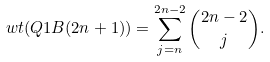Convert formula to latex. <formula><loc_0><loc_0><loc_500><loc_500>w t ( Q 1 B ( 2 n + 1 ) ) = \sum _ { j = n } ^ { 2 n - 2 } \binom { 2 n - 2 } { j } .</formula> 